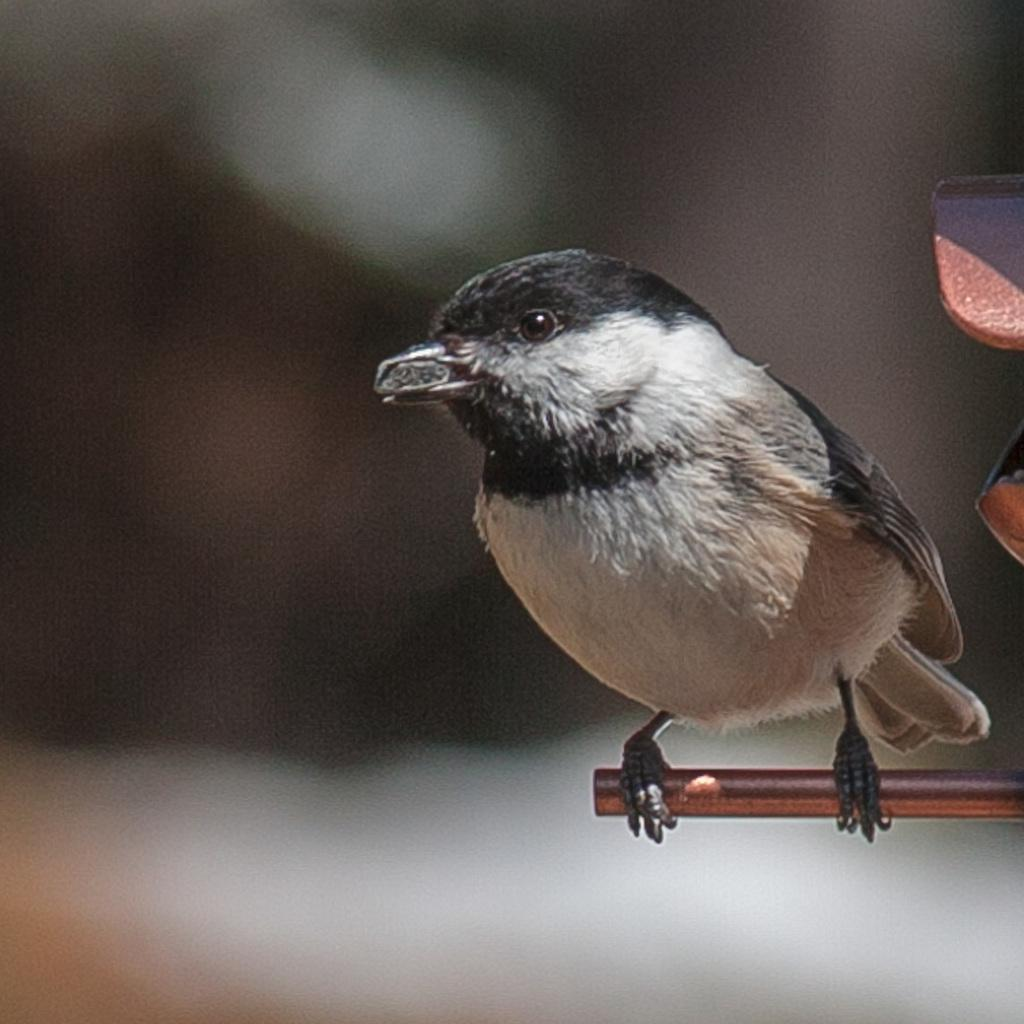What type of animal is in the image? There is a bird in the image. Where is the bird located? The bird is on a stand. Can you describe the background of the image? The background of the image is not clear. What type of leather is the bird sitting on in the image? There is no leather present in the image; the bird is on a stand. What flavor of mint can be seen in the image? There is no mint present in the image. 